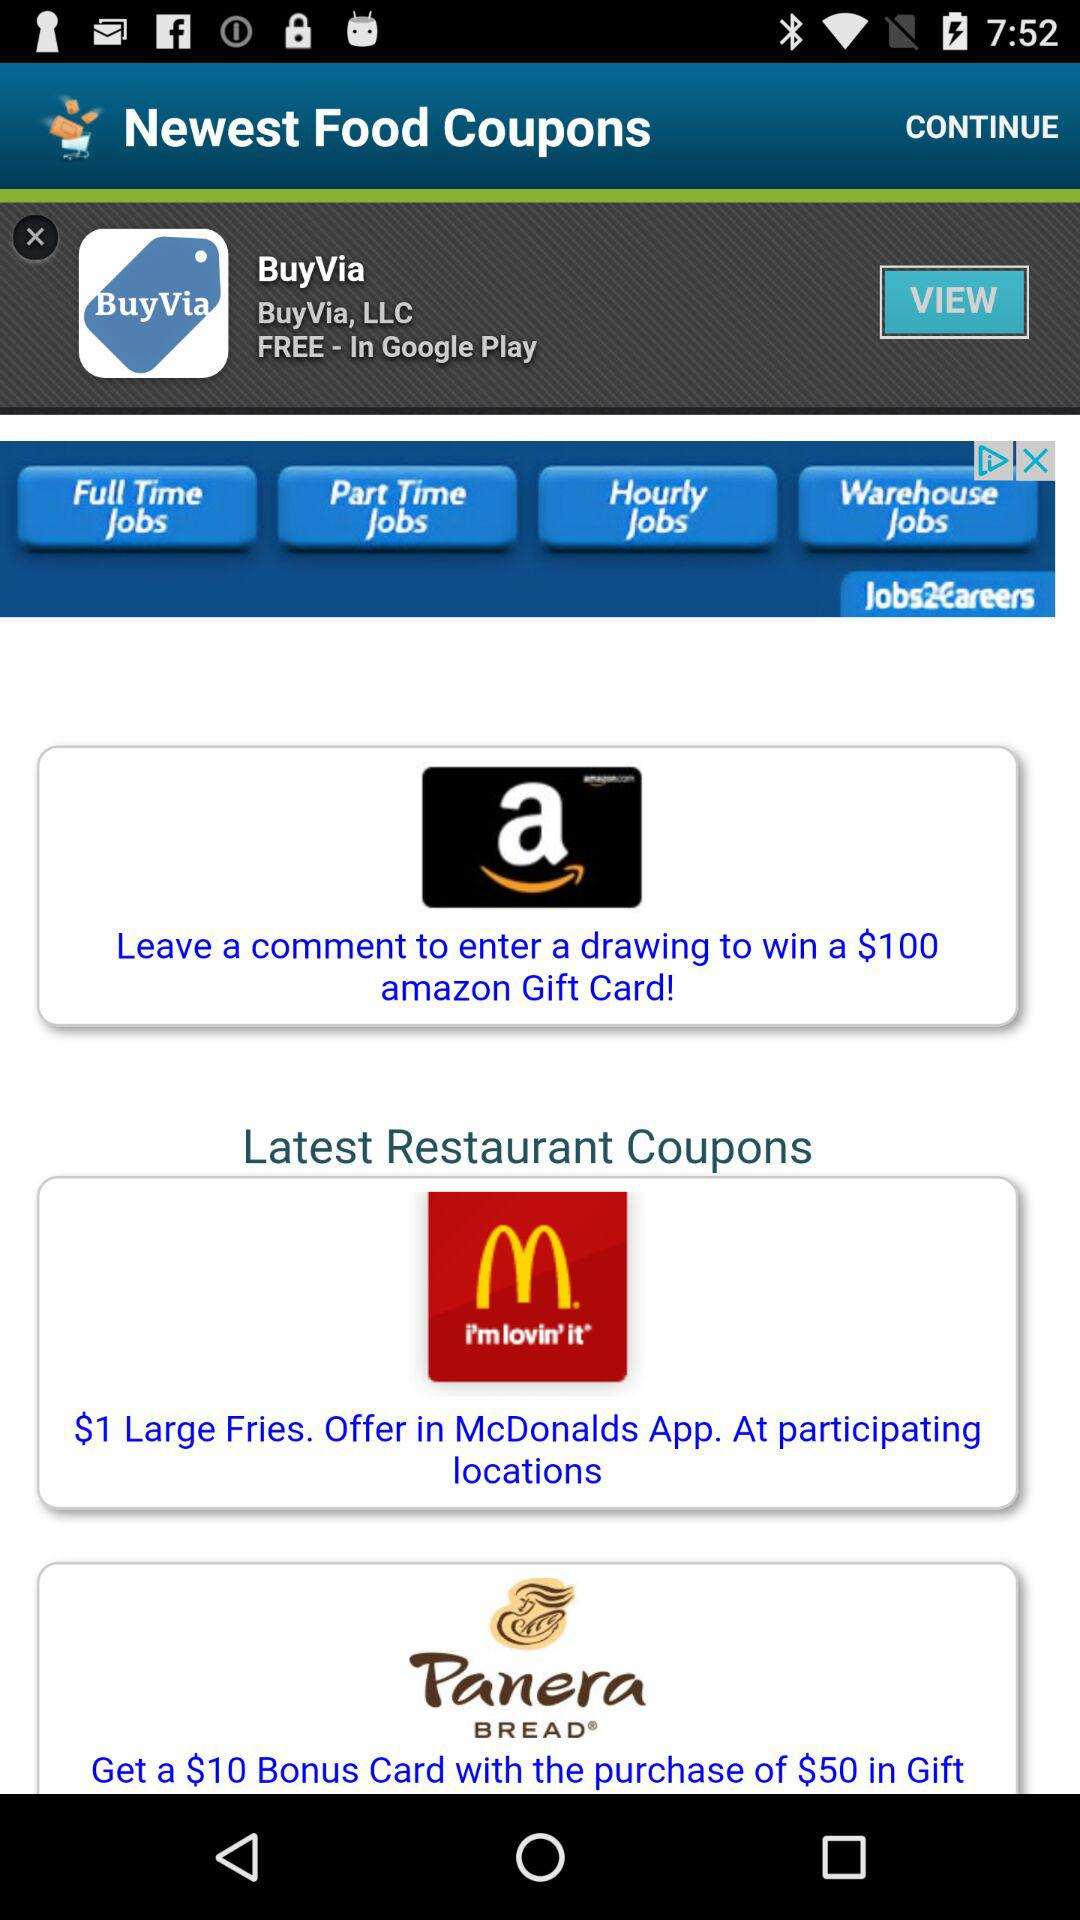How much do the large fries cost? The large fries cost $1. 